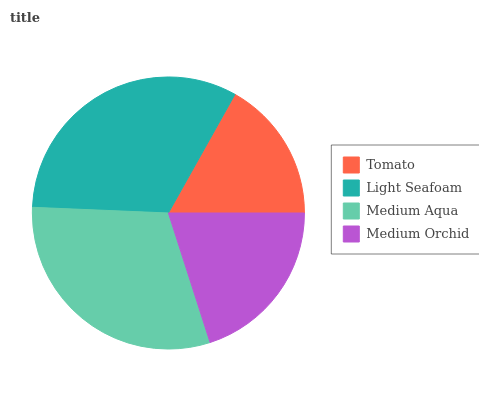Is Tomato the minimum?
Answer yes or no. Yes. Is Light Seafoam the maximum?
Answer yes or no. Yes. Is Medium Aqua the minimum?
Answer yes or no. No. Is Medium Aqua the maximum?
Answer yes or no. No. Is Light Seafoam greater than Medium Aqua?
Answer yes or no. Yes. Is Medium Aqua less than Light Seafoam?
Answer yes or no. Yes. Is Medium Aqua greater than Light Seafoam?
Answer yes or no. No. Is Light Seafoam less than Medium Aqua?
Answer yes or no. No. Is Medium Aqua the high median?
Answer yes or no. Yes. Is Medium Orchid the low median?
Answer yes or no. Yes. Is Tomato the high median?
Answer yes or no. No. Is Light Seafoam the low median?
Answer yes or no. No. 